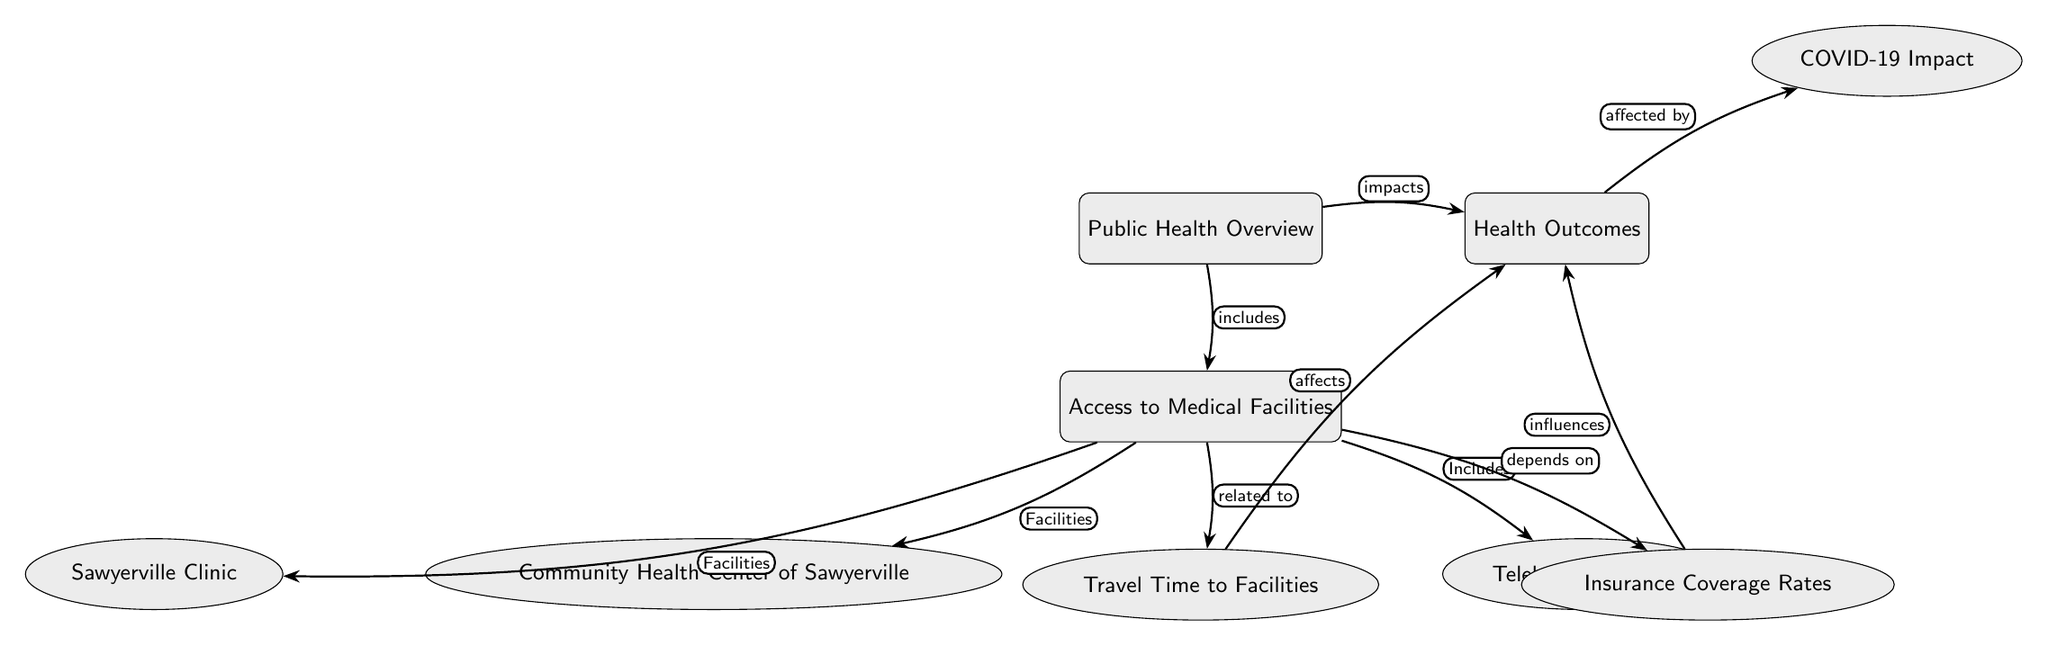What is the main topic of the diagram? The main node at the top of the diagram is labeled "Public Health Overview," indicating that this is the central theme being explored.
Answer: Public Health Overview How many secondary nodes are connected to "Access to Medical Facilities"? There are three secondary nodes connected to "Access to Medical Facilities," which are "Community Health Center of Sawyerville," "Sawyerville Clinic," and "Telehealth Services."
Answer: 3 What does "Travel Time to Facilities" affect? In the diagram, "Travel Time to Facilities" is indicated to affect "Health Outcomes," showing the link between how far people need to travel and their health.
Answer: Health Outcomes Which node is related to "Insurance Coverage Rates"? "Insurance Coverage Rates" is related to "Access to Medical Facilities," indicating that insurance availability has an influence on access to medical services.
Answer: Access to Medical Facilities What type of impact does "COVID-19 Impact" have? "COVID-19 Impact" is mentioned as being affected by "Health Outcomes," suggesting that the health outcomes of individuals may have changed due to the pandemic.
Answer: affected by What includes "Access to Medical Facilities"? The main node "Public Health Overview" includes "Access to Medical Facilities," which indicates that understanding public health requires looking at the availability of medical services.
Answer: Access to Medical Facilities What is the relationship between "Insurance Coverage Rates" and "Health Outcomes"? "Insurance Coverage Rates" influences "Health Outcomes," meaning that the extent of coverage can have a direct effect on the health results of individuals in the area.
Answer: influences Which facilities are listed under "Access to Medical Facilities"? The facilities listed under "Access to Medical Facilities" include "Community Health Center of Sawyerville," "Sawyerville Clinic," and "Telehealth Services."
Answer: Community Health Center of Sawyerville, Sawyerville Clinic, Telehealth Services What does the edge connecting "Travel Time" and "Health Outcomes" indicate? The edge denotes that "Travel Time" has an impact on "Health Outcomes," suggesting that longer travel times may lead to poorer health outcomes for individuals.
Answer: affects 